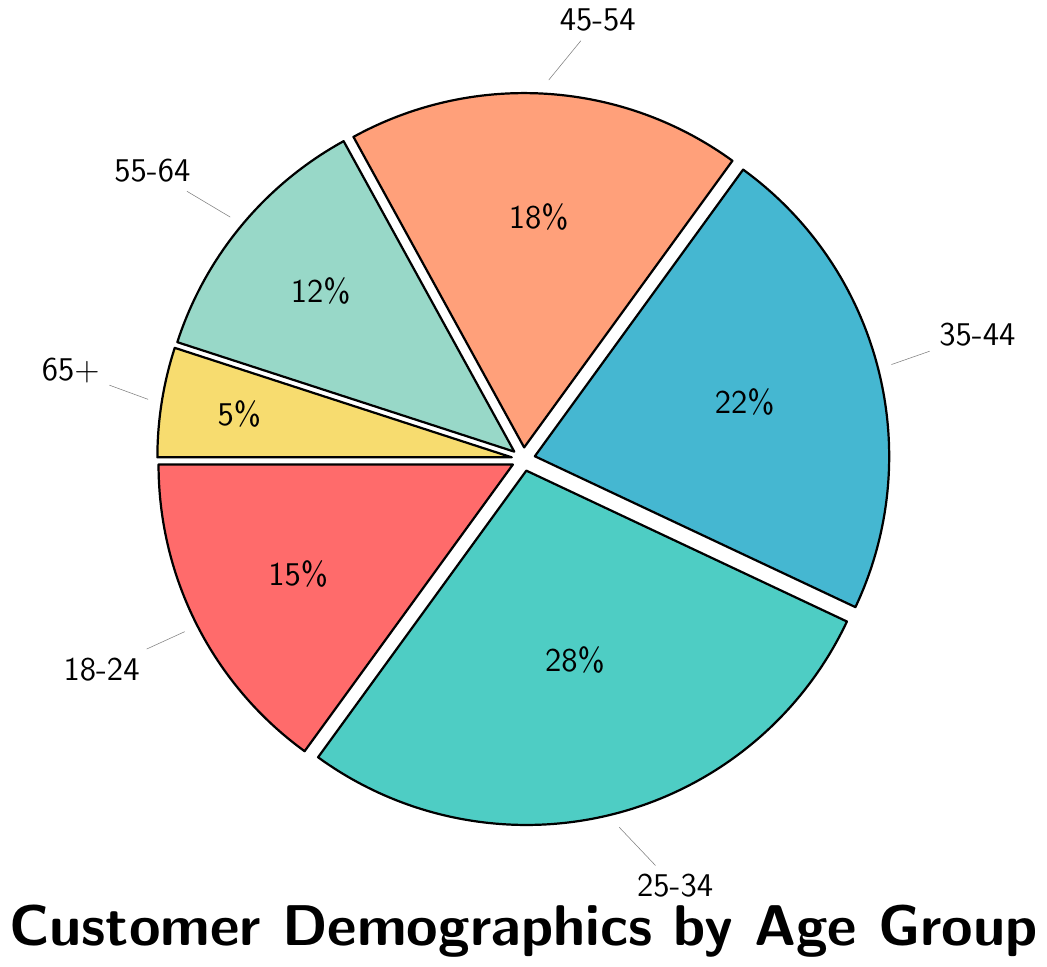What's the largest age group represented in the pie chart? By looking at the pie chart, the largest portion is marked for the age group 25-34 with 28%.
Answer: 25-34 Which two age groups have the closest percentages, and what are their values? The two age groups closest in percentages are 35-44 and 45-54 with 22% and 18% respectively.
Answer: 35-44 and 45-54, 22% and 18% How do the combined percentages of age groups 18-24 and 55-64 compare to the percentage of 25-34? Adding the percentages of age groups 18-24 and 55-64 gives 15% + 12% = 27%, which is 1% less than the 28% for age group 25-34.
Answer: 27%, 1% less What is the percentage difference between the youngest age group (18-24) and the oldest age group (65+)? Subtracting the percentage of the oldest age group (65+) from the youngest age group (18-24) gives 15% - 5% = 10%.
Answer: 10% How much more is the percentage of the age group 35-44 compared to the age group 55-64? Subtracting the percentage of 55-64 from 35-44, we get 22% - 12% = 10%.
Answer: 10% What percentage of the population is under 35 years old? Adding the percentages of age groups 18-24 and 25-34, we get 15% + 28% = 43%.
Answer: 43% Compare the proportions of the age groups 45-54 and 55-64. Which one is larger and by how much? Comparing the two age groups, 45-54 has 18% and 55-64 has 12%. Subtracting the smaller percentage from the larger, 18% - 12%, we get 6%.
Answer: 45-54, 6% If we combine the age groups into under 45 and 45 and over, what percentage of the population is each category? Adding the percentages for age groups under 45: 15% (18-24) + 28% (25-34) + 22% (35-44) = 65%. For 45 and over: 18% (45-54) + 12% (55-64) + 5% (65+) = 35%.
Answer: Under 45: 65%, 45 and over: 35% Which age group occupies the green color in the pie chart, and what is its percentage? The green color in the pie chart is used for the age group 45-54, which has a percentage of 18%.
Answer: 45-54, 18% How do the percentages of age groups 35-44 and 55-64 compare, and what is the visual difference between these two segments in the chart? The percentage of the age group 35-44 (22%) is larger than the age group 55-64 (12%). Visually, the 35-44 segment is nearly twice as large as the 55-64 segment in the pie chart.
Answer: 35-44 > 55-64, 22% vs. 12% 